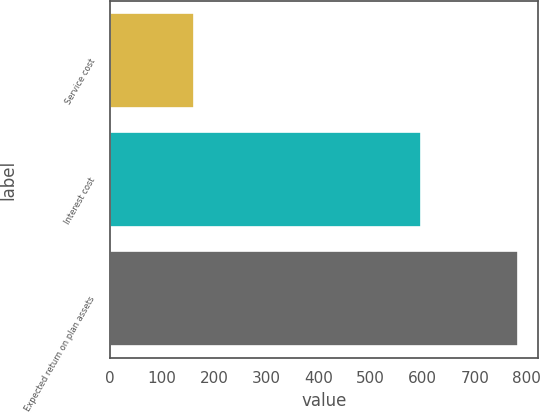<chart> <loc_0><loc_0><loc_500><loc_500><bar_chart><fcel>Service cost<fcel>Interest cost<fcel>Expected return on plan assets<nl><fcel>161<fcel>597<fcel>783<nl></chart> 